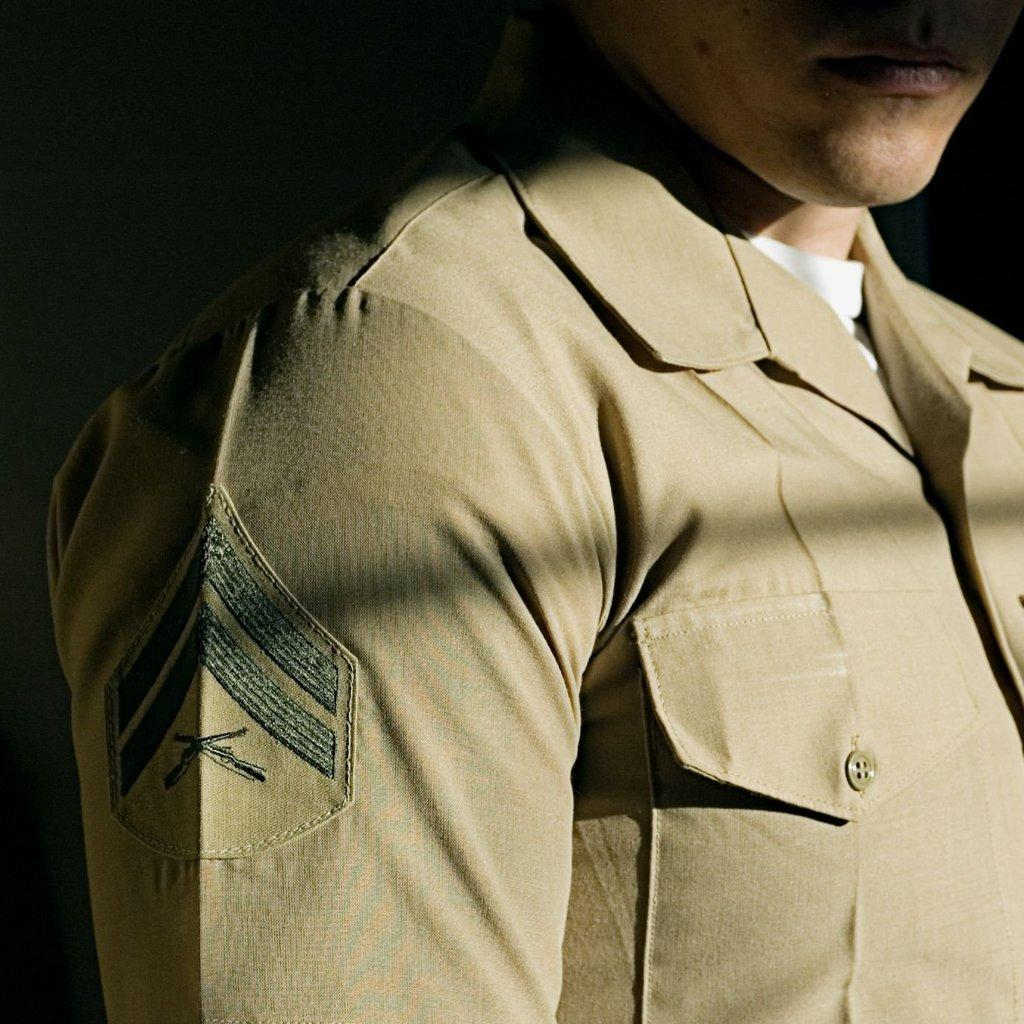What is the main subject of the image? There is a person in the image. What is the person wearing in the image? The person is wearing a uniform. What type of bird can be seen perched on the person's shoulder in the image? There is no bird present in the image. What belief system does the person in the image follow? There is no information about the person's belief system in the image. Is the person in the image currently incarcerated? There is no indication in the image that the person is in jail or incarcerated. 